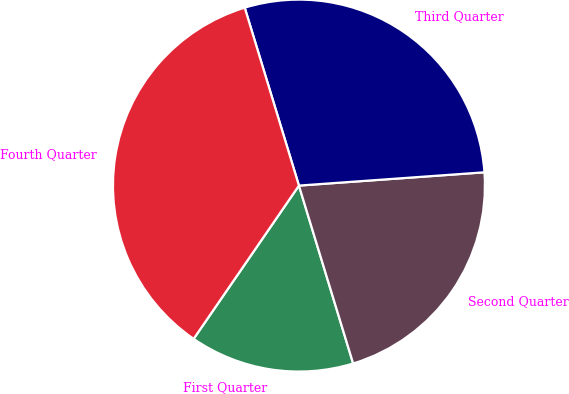Convert chart to OTSL. <chart><loc_0><loc_0><loc_500><loc_500><pie_chart><fcel>First Quarter<fcel>Second Quarter<fcel>Third Quarter<fcel>Fourth Quarter<nl><fcel>14.29%<fcel>21.43%<fcel>28.57%<fcel>35.71%<nl></chart> 